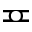Convert formula to latex. <formula><loc_0><loc_0><loc_500><loc_500>\ e q c i r c</formula> 